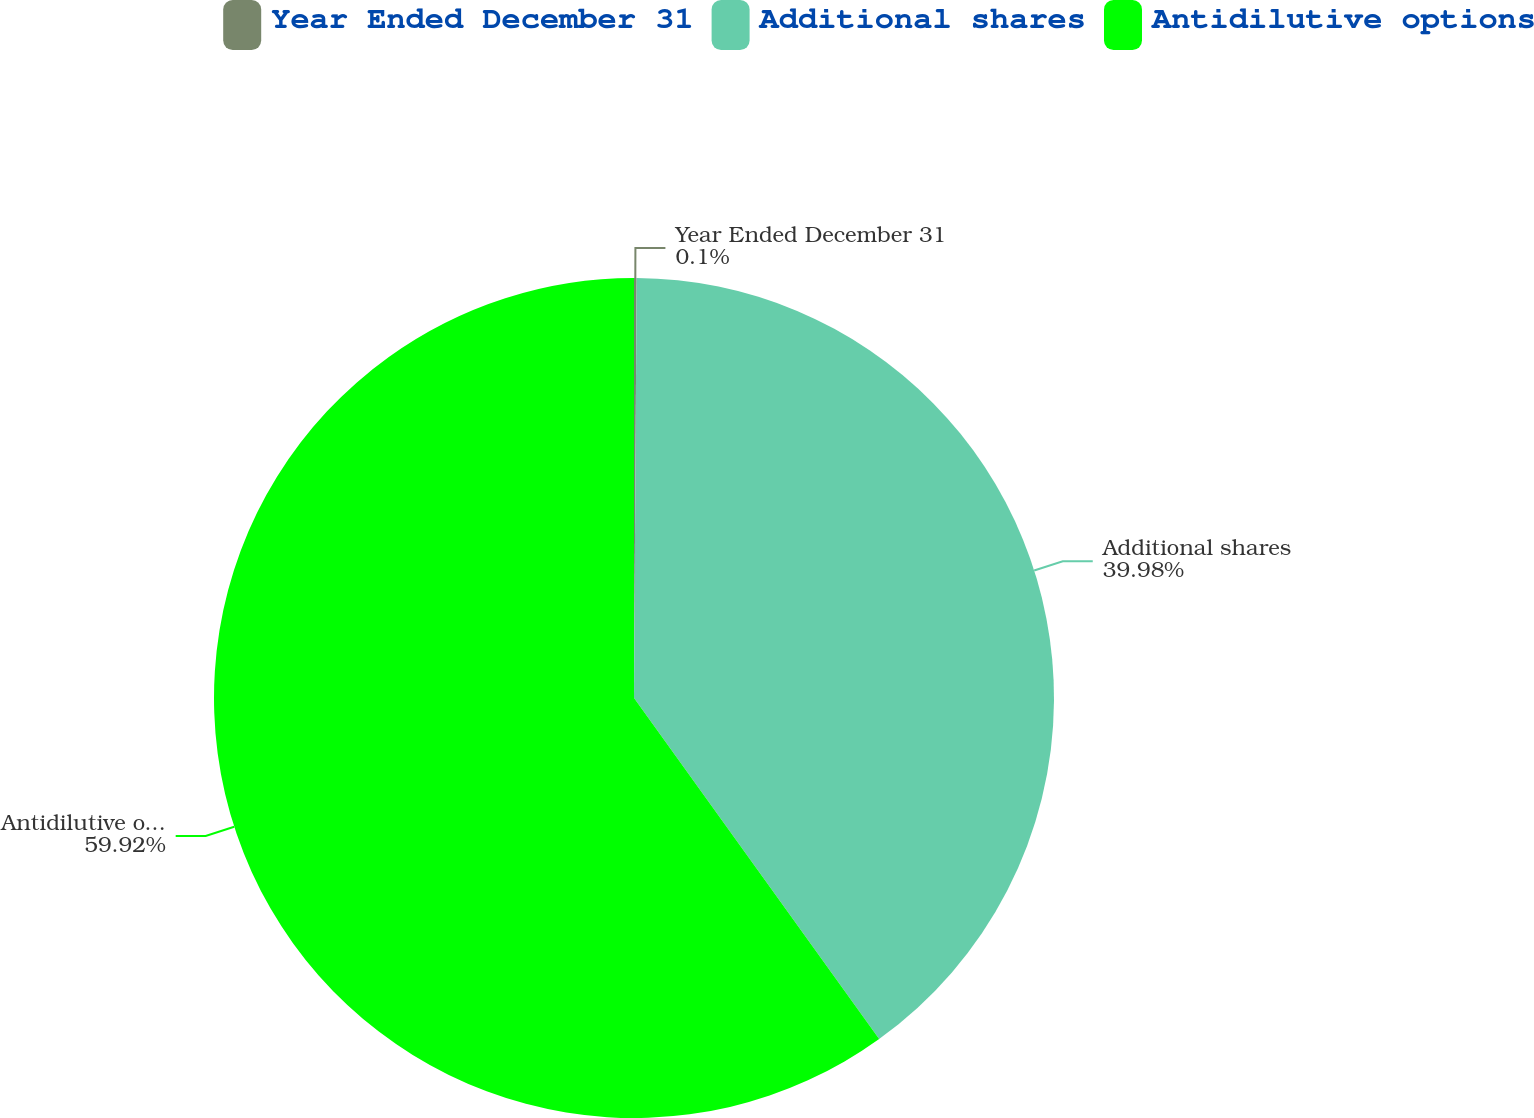Convert chart. <chart><loc_0><loc_0><loc_500><loc_500><pie_chart><fcel>Year Ended December 31<fcel>Additional shares<fcel>Antidilutive options<nl><fcel>0.1%<fcel>39.98%<fcel>59.92%<nl></chart> 